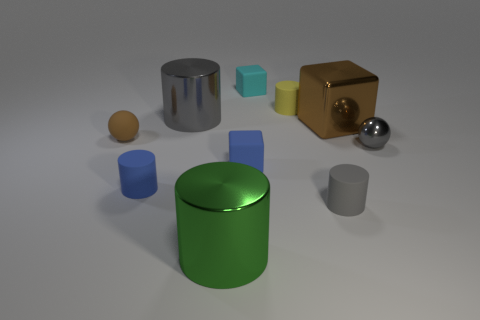Which objects in the image are reflective? The objects with reflective surfaces in this image include the small gray metallic sphere and the golden cube. Their shiny exteriors clearly show the environment's reflection, while the others have matte surfaces that do not reflect as prominently. 